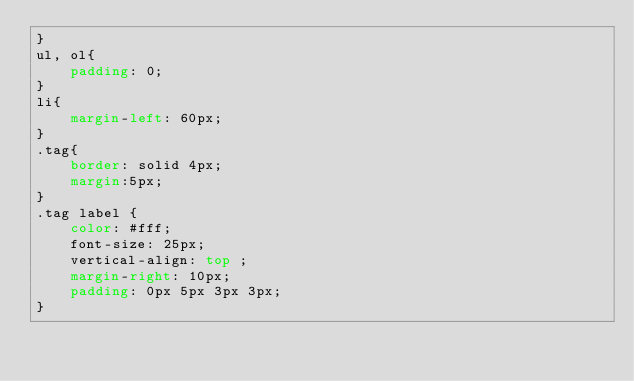<code> <loc_0><loc_0><loc_500><loc_500><_CSS_>}
ul, ol{
    padding: 0;
}
li{
    margin-left: 60px;
}
.tag{
    border: solid 4px;
    margin:5px;
}
.tag label {
    color: #fff;
    font-size: 25px;
    vertical-align: top ;
    margin-right: 10px;
    padding: 0px 5px 3px 3px;
} 
 </code> 